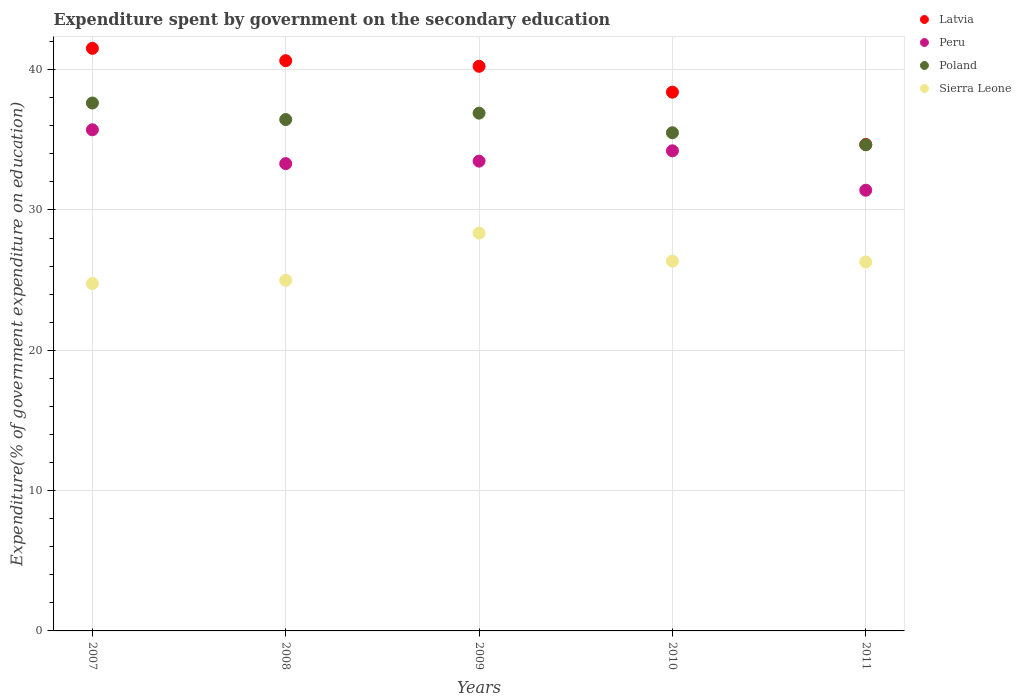Is the number of dotlines equal to the number of legend labels?
Ensure brevity in your answer.  Yes. What is the expenditure spent by government on the secondary education in Poland in 2009?
Ensure brevity in your answer.  36.9. Across all years, what is the maximum expenditure spent by government on the secondary education in Peru?
Make the answer very short. 35.71. Across all years, what is the minimum expenditure spent by government on the secondary education in Latvia?
Your response must be concise. 34.67. What is the total expenditure spent by government on the secondary education in Sierra Leone in the graph?
Offer a terse response. 130.74. What is the difference between the expenditure spent by government on the secondary education in Sierra Leone in 2007 and that in 2009?
Your answer should be very brief. -3.59. What is the difference between the expenditure spent by government on the secondary education in Sierra Leone in 2007 and the expenditure spent by government on the secondary education in Poland in 2009?
Offer a very short reply. -12.14. What is the average expenditure spent by government on the secondary education in Poland per year?
Your answer should be compact. 36.22. In the year 2011, what is the difference between the expenditure spent by government on the secondary education in Poland and expenditure spent by government on the secondary education in Peru?
Your answer should be very brief. 3.24. In how many years, is the expenditure spent by government on the secondary education in Poland greater than 10 %?
Provide a short and direct response. 5. What is the ratio of the expenditure spent by government on the secondary education in Latvia in 2007 to that in 2008?
Your response must be concise. 1.02. Is the expenditure spent by government on the secondary education in Peru in 2008 less than that in 2011?
Provide a succinct answer. No. What is the difference between the highest and the second highest expenditure spent by government on the secondary education in Poland?
Your answer should be very brief. 0.72. What is the difference between the highest and the lowest expenditure spent by government on the secondary education in Peru?
Provide a short and direct response. 4.31. In how many years, is the expenditure spent by government on the secondary education in Poland greater than the average expenditure spent by government on the secondary education in Poland taken over all years?
Offer a very short reply. 3. Is the sum of the expenditure spent by government on the secondary education in Sierra Leone in 2007 and 2010 greater than the maximum expenditure spent by government on the secondary education in Poland across all years?
Give a very brief answer. Yes. Is it the case that in every year, the sum of the expenditure spent by government on the secondary education in Latvia and expenditure spent by government on the secondary education in Sierra Leone  is greater than the expenditure spent by government on the secondary education in Poland?
Give a very brief answer. Yes. How many years are there in the graph?
Offer a terse response. 5. Where does the legend appear in the graph?
Your answer should be very brief. Top right. How many legend labels are there?
Offer a very short reply. 4. How are the legend labels stacked?
Make the answer very short. Vertical. What is the title of the graph?
Give a very brief answer. Expenditure spent by government on the secondary education. Does "Uruguay" appear as one of the legend labels in the graph?
Provide a short and direct response. No. What is the label or title of the X-axis?
Your response must be concise. Years. What is the label or title of the Y-axis?
Keep it short and to the point. Expenditure(% of government expenditure on education). What is the Expenditure(% of government expenditure on education) in Latvia in 2007?
Offer a terse response. 41.52. What is the Expenditure(% of government expenditure on education) in Peru in 2007?
Provide a short and direct response. 35.71. What is the Expenditure(% of government expenditure on education) of Poland in 2007?
Provide a short and direct response. 37.62. What is the Expenditure(% of government expenditure on education) of Sierra Leone in 2007?
Make the answer very short. 24.76. What is the Expenditure(% of government expenditure on education) of Latvia in 2008?
Your answer should be very brief. 40.64. What is the Expenditure(% of government expenditure on education) of Peru in 2008?
Your answer should be compact. 33.3. What is the Expenditure(% of government expenditure on education) in Poland in 2008?
Your answer should be very brief. 36.44. What is the Expenditure(% of government expenditure on education) of Sierra Leone in 2008?
Give a very brief answer. 24.99. What is the Expenditure(% of government expenditure on education) in Latvia in 2009?
Offer a very short reply. 40.24. What is the Expenditure(% of government expenditure on education) in Peru in 2009?
Offer a terse response. 33.48. What is the Expenditure(% of government expenditure on education) of Poland in 2009?
Offer a terse response. 36.9. What is the Expenditure(% of government expenditure on education) of Sierra Leone in 2009?
Offer a very short reply. 28.35. What is the Expenditure(% of government expenditure on education) of Latvia in 2010?
Make the answer very short. 38.39. What is the Expenditure(% of government expenditure on education) in Peru in 2010?
Ensure brevity in your answer.  34.22. What is the Expenditure(% of government expenditure on education) in Poland in 2010?
Your answer should be very brief. 35.5. What is the Expenditure(% of government expenditure on education) in Sierra Leone in 2010?
Your response must be concise. 26.36. What is the Expenditure(% of government expenditure on education) of Latvia in 2011?
Provide a short and direct response. 34.67. What is the Expenditure(% of government expenditure on education) of Peru in 2011?
Offer a terse response. 31.41. What is the Expenditure(% of government expenditure on education) of Poland in 2011?
Offer a terse response. 34.64. What is the Expenditure(% of government expenditure on education) of Sierra Leone in 2011?
Make the answer very short. 26.29. Across all years, what is the maximum Expenditure(% of government expenditure on education) of Latvia?
Keep it short and to the point. 41.52. Across all years, what is the maximum Expenditure(% of government expenditure on education) of Peru?
Your response must be concise. 35.71. Across all years, what is the maximum Expenditure(% of government expenditure on education) in Poland?
Offer a very short reply. 37.62. Across all years, what is the maximum Expenditure(% of government expenditure on education) in Sierra Leone?
Your answer should be compact. 28.35. Across all years, what is the minimum Expenditure(% of government expenditure on education) of Latvia?
Provide a succinct answer. 34.67. Across all years, what is the minimum Expenditure(% of government expenditure on education) of Peru?
Keep it short and to the point. 31.41. Across all years, what is the minimum Expenditure(% of government expenditure on education) in Poland?
Give a very brief answer. 34.64. Across all years, what is the minimum Expenditure(% of government expenditure on education) of Sierra Leone?
Your answer should be compact. 24.76. What is the total Expenditure(% of government expenditure on education) in Latvia in the graph?
Your answer should be very brief. 195.45. What is the total Expenditure(% of government expenditure on education) of Peru in the graph?
Provide a succinct answer. 168.11. What is the total Expenditure(% of government expenditure on education) in Poland in the graph?
Offer a terse response. 181.11. What is the total Expenditure(% of government expenditure on education) of Sierra Leone in the graph?
Keep it short and to the point. 130.74. What is the difference between the Expenditure(% of government expenditure on education) of Latvia in 2007 and that in 2008?
Keep it short and to the point. 0.88. What is the difference between the Expenditure(% of government expenditure on education) in Peru in 2007 and that in 2008?
Offer a very short reply. 2.41. What is the difference between the Expenditure(% of government expenditure on education) of Poland in 2007 and that in 2008?
Make the answer very short. 1.18. What is the difference between the Expenditure(% of government expenditure on education) in Sierra Leone in 2007 and that in 2008?
Your answer should be very brief. -0.23. What is the difference between the Expenditure(% of government expenditure on education) of Latvia in 2007 and that in 2009?
Your answer should be very brief. 1.28. What is the difference between the Expenditure(% of government expenditure on education) of Peru in 2007 and that in 2009?
Ensure brevity in your answer.  2.23. What is the difference between the Expenditure(% of government expenditure on education) in Poland in 2007 and that in 2009?
Give a very brief answer. 0.72. What is the difference between the Expenditure(% of government expenditure on education) in Sierra Leone in 2007 and that in 2009?
Provide a succinct answer. -3.59. What is the difference between the Expenditure(% of government expenditure on education) of Latvia in 2007 and that in 2010?
Provide a succinct answer. 3.12. What is the difference between the Expenditure(% of government expenditure on education) of Peru in 2007 and that in 2010?
Ensure brevity in your answer.  1.5. What is the difference between the Expenditure(% of government expenditure on education) in Poland in 2007 and that in 2010?
Provide a short and direct response. 2.12. What is the difference between the Expenditure(% of government expenditure on education) in Sierra Leone in 2007 and that in 2010?
Provide a succinct answer. -1.6. What is the difference between the Expenditure(% of government expenditure on education) in Latvia in 2007 and that in 2011?
Provide a short and direct response. 6.85. What is the difference between the Expenditure(% of government expenditure on education) of Peru in 2007 and that in 2011?
Make the answer very short. 4.31. What is the difference between the Expenditure(% of government expenditure on education) of Poland in 2007 and that in 2011?
Provide a short and direct response. 2.98. What is the difference between the Expenditure(% of government expenditure on education) in Sierra Leone in 2007 and that in 2011?
Your answer should be compact. -1.54. What is the difference between the Expenditure(% of government expenditure on education) of Latvia in 2008 and that in 2009?
Offer a very short reply. 0.4. What is the difference between the Expenditure(% of government expenditure on education) of Peru in 2008 and that in 2009?
Provide a succinct answer. -0.18. What is the difference between the Expenditure(% of government expenditure on education) in Poland in 2008 and that in 2009?
Your response must be concise. -0.46. What is the difference between the Expenditure(% of government expenditure on education) of Sierra Leone in 2008 and that in 2009?
Your answer should be very brief. -3.36. What is the difference between the Expenditure(% of government expenditure on education) of Latvia in 2008 and that in 2010?
Your response must be concise. 2.24. What is the difference between the Expenditure(% of government expenditure on education) of Peru in 2008 and that in 2010?
Offer a very short reply. -0.91. What is the difference between the Expenditure(% of government expenditure on education) in Poland in 2008 and that in 2010?
Keep it short and to the point. 0.94. What is the difference between the Expenditure(% of government expenditure on education) of Sierra Leone in 2008 and that in 2010?
Make the answer very short. -1.37. What is the difference between the Expenditure(% of government expenditure on education) in Latvia in 2008 and that in 2011?
Your answer should be compact. 5.97. What is the difference between the Expenditure(% of government expenditure on education) in Peru in 2008 and that in 2011?
Ensure brevity in your answer.  1.9. What is the difference between the Expenditure(% of government expenditure on education) in Poland in 2008 and that in 2011?
Offer a very short reply. 1.8. What is the difference between the Expenditure(% of government expenditure on education) in Sierra Leone in 2008 and that in 2011?
Offer a terse response. -1.31. What is the difference between the Expenditure(% of government expenditure on education) of Latvia in 2009 and that in 2010?
Your answer should be very brief. 1.84. What is the difference between the Expenditure(% of government expenditure on education) in Peru in 2009 and that in 2010?
Your answer should be compact. -0.74. What is the difference between the Expenditure(% of government expenditure on education) in Poland in 2009 and that in 2010?
Provide a short and direct response. 1.4. What is the difference between the Expenditure(% of government expenditure on education) of Sierra Leone in 2009 and that in 2010?
Make the answer very short. 1.99. What is the difference between the Expenditure(% of government expenditure on education) in Latvia in 2009 and that in 2011?
Provide a short and direct response. 5.57. What is the difference between the Expenditure(% of government expenditure on education) of Peru in 2009 and that in 2011?
Provide a succinct answer. 2.07. What is the difference between the Expenditure(% of government expenditure on education) of Poland in 2009 and that in 2011?
Keep it short and to the point. 2.25. What is the difference between the Expenditure(% of government expenditure on education) of Sierra Leone in 2009 and that in 2011?
Give a very brief answer. 2.06. What is the difference between the Expenditure(% of government expenditure on education) in Latvia in 2010 and that in 2011?
Keep it short and to the point. 3.73. What is the difference between the Expenditure(% of government expenditure on education) of Peru in 2010 and that in 2011?
Give a very brief answer. 2.81. What is the difference between the Expenditure(% of government expenditure on education) in Poland in 2010 and that in 2011?
Offer a terse response. 0.86. What is the difference between the Expenditure(% of government expenditure on education) in Sierra Leone in 2010 and that in 2011?
Your answer should be compact. 0.06. What is the difference between the Expenditure(% of government expenditure on education) of Latvia in 2007 and the Expenditure(% of government expenditure on education) of Peru in 2008?
Provide a succinct answer. 8.22. What is the difference between the Expenditure(% of government expenditure on education) in Latvia in 2007 and the Expenditure(% of government expenditure on education) in Poland in 2008?
Offer a very short reply. 5.08. What is the difference between the Expenditure(% of government expenditure on education) of Latvia in 2007 and the Expenditure(% of government expenditure on education) of Sierra Leone in 2008?
Your response must be concise. 16.53. What is the difference between the Expenditure(% of government expenditure on education) in Peru in 2007 and the Expenditure(% of government expenditure on education) in Poland in 2008?
Offer a terse response. -0.73. What is the difference between the Expenditure(% of government expenditure on education) of Peru in 2007 and the Expenditure(% of government expenditure on education) of Sierra Leone in 2008?
Offer a terse response. 10.73. What is the difference between the Expenditure(% of government expenditure on education) of Poland in 2007 and the Expenditure(% of government expenditure on education) of Sierra Leone in 2008?
Your answer should be compact. 12.63. What is the difference between the Expenditure(% of government expenditure on education) in Latvia in 2007 and the Expenditure(% of government expenditure on education) in Peru in 2009?
Provide a short and direct response. 8.04. What is the difference between the Expenditure(% of government expenditure on education) in Latvia in 2007 and the Expenditure(% of government expenditure on education) in Poland in 2009?
Make the answer very short. 4.62. What is the difference between the Expenditure(% of government expenditure on education) of Latvia in 2007 and the Expenditure(% of government expenditure on education) of Sierra Leone in 2009?
Your answer should be very brief. 13.17. What is the difference between the Expenditure(% of government expenditure on education) of Peru in 2007 and the Expenditure(% of government expenditure on education) of Poland in 2009?
Your response must be concise. -1.19. What is the difference between the Expenditure(% of government expenditure on education) in Peru in 2007 and the Expenditure(% of government expenditure on education) in Sierra Leone in 2009?
Your answer should be compact. 7.36. What is the difference between the Expenditure(% of government expenditure on education) of Poland in 2007 and the Expenditure(% of government expenditure on education) of Sierra Leone in 2009?
Make the answer very short. 9.27. What is the difference between the Expenditure(% of government expenditure on education) in Latvia in 2007 and the Expenditure(% of government expenditure on education) in Peru in 2010?
Ensure brevity in your answer.  7.3. What is the difference between the Expenditure(% of government expenditure on education) in Latvia in 2007 and the Expenditure(% of government expenditure on education) in Poland in 2010?
Your response must be concise. 6.01. What is the difference between the Expenditure(% of government expenditure on education) in Latvia in 2007 and the Expenditure(% of government expenditure on education) in Sierra Leone in 2010?
Your response must be concise. 15.16. What is the difference between the Expenditure(% of government expenditure on education) of Peru in 2007 and the Expenditure(% of government expenditure on education) of Poland in 2010?
Keep it short and to the point. 0.21. What is the difference between the Expenditure(% of government expenditure on education) of Peru in 2007 and the Expenditure(% of government expenditure on education) of Sierra Leone in 2010?
Ensure brevity in your answer.  9.36. What is the difference between the Expenditure(% of government expenditure on education) of Poland in 2007 and the Expenditure(% of government expenditure on education) of Sierra Leone in 2010?
Your answer should be very brief. 11.26. What is the difference between the Expenditure(% of government expenditure on education) of Latvia in 2007 and the Expenditure(% of government expenditure on education) of Peru in 2011?
Provide a short and direct response. 10.11. What is the difference between the Expenditure(% of government expenditure on education) of Latvia in 2007 and the Expenditure(% of government expenditure on education) of Poland in 2011?
Offer a terse response. 6.87. What is the difference between the Expenditure(% of government expenditure on education) of Latvia in 2007 and the Expenditure(% of government expenditure on education) of Sierra Leone in 2011?
Ensure brevity in your answer.  15.22. What is the difference between the Expenditure(% of government expenditure on education) in Peru in 2007 and the Expenditure(% of government expenditure on education) in Poland in 2011?
Provide a short and direct response. 1.07. What is the difference between the Expenditure(% of government expenditure on education) in Peru in 2007 and the Expenditure(% of government expenditure on education) in Sierra Leone in 2011?
Ensure brevity in your answer.  9.42. What is the difference between the Expenditure(% of government expenditure on education) of Poland in 2007 and the Expenditure(% of government expenditure on education) of Sierra Leone in 2011?
Give a very brief answer. 11.33. What is the difference between the Expenditure(% of government expenditure on education) of Latvia in 2008 and the Expenditure(% of government expenditure on education) of Peru in 2009?
Give a very brief answer. 7.16. What is the difference between the Expenditure(% of government expenditure on education) in Latvia in 2008 and the Expenditure(% of government expenditure on education) in Poland in 2009?
Provide a short and direct response. 3.74. What is the difference between the Expenditure(% of government expenditure on education) in Latvia in 2008 and the Expenditure(% of government expenditure on education) in Sierra Leone in 2009?
Ensure brevity in your answer.  12.29. What is the difference between the Expenditure(% of government expenditure on education) of Peru in 2008 and the Expenditure(% of government expenditure on education) of Poland in 2009?
Give a very brief answer. -3.6. What is the difference between the Expenditure(% of government expenditure on education) in Peru in 2008 and the Expenditure(% of government expenditure on education) in Sierra Leone in 2009?
Ensure brevity in your answer.  4.95. What is the difference between the Expenditure(% of government expenditure on education) of Poland in 2008 and the Expenditure(% of government expenditure on education) of Sierra Leone in 2009?
Keep it short and to the point. 8.09. What is the difference between the Expenditure(% of government expenditure on education) in Latvia in 2008 and the Expenditure(% of government expenditure on education) in Peru in 2010?
Offer a terse response. 6.42. What is the difference between the Expenditure(% of government expenditure on education) of Latvia in 2008 and the Expenditure(% of government expenditure on education) of Poland in 2010?
Your answer should be compact. 5.13. What is the difference between the Expenditure(% of government expenditure on education) of Latvia in 2008 and the Expenditure(% of government expenditure on education) of Sierra Leone in 2010?
Ensure brevity in your answer.  14.28. What is the difference between the Expenditure(% of government expenditure on education) of Peru in 2008 and the Expenditure(% of government expenditure on education) of Poland in 2010?
Offer a terse response. -2.2. What is the difference between the Expenditure(% of government expenditure on education) in Peru in 2008 and the Expenditure(% of government expenditure on education) in Sierra Leone in 2010?
Make the answer very short. 6.95. What is the difference between the Expenditure(% of government expenditure on education) in Poland in 2008 and the Expenditure(% of government expenditure on education) in Sierra Leone in 2010?
Give a very brief answer. 10.09. What is the difference between the Expenditure(% of government expenditure on education) of Latvia in 2008 and the Expenditure(% of government expenditure on education) of Peru in 2011?
Offer a terse response. 9.23. What is the difference between the Expenditure(% of government expenditure on education) in Latvia in 2008 and the Expenditure(% of government expenditure on education) in Poland in 2011?
Your response must be concise. 5.99. What is the difference between the Expenditure(% of government expenditure on education) of Latvia in 2008 and the Expenditure(% of government expenditure on education) of Sierra Leone in 2011?
Offer a very short reply. 14.34. What is the difference between the Expenditure(% of government expenditure on education) in Peru in 2008 and the Expenditure(% of government expenditure on education) in Poland in 2011?
Your answer should be very brief. -1.34. What is the difference between the Expenditure(% of government expenditure on education) of Peru in 2008 and the Expenditure(% of government expenditure on education) of Sierra Leone in 2011?
Make the answer very short. 7.01. What is the difference between the Expenditure(% of government expenditure on education) in Poland in 2008 and the Expenditure(% of government expenditure on education) in Sierra Leone in 2011?
Your answer should be very brief. 10.15. What is the difference between the Expenditure(% of government expenditure on education) in Latvia in 2009 and the Expenditure(% of government expenditure on education) in Peru in 2010?
Offer a very short reply. 6.02. What is the difference between the Expenditure(% of government expenditure on education) in Latvia in 2009 and the Expenditure(% of government expenditure on education) in Poland in 2010?
Make the answer very short. 4.73. What is the difference between the Expenditure(% of government expenditure on education) in Latvia in 2009 and the Expenditure(% of government expenditure on education) in Sierra Leone in 2010?
Provide a short and direct response. 13.88. What is the difference between the Expenditure(% of government expenditure on education) in Peru in 2009 and the Expenditure(% of government expenditure on education) in Poland in 2010?
Provide a succinct answer. -2.02. What is the difference between the Expenditure(% of government expenditure on education) of Peru in 2009 and the Expenditure(% of government expenditure on education) of Sierra Leone in 2010?
Your answer should be very brief. 7.12. What is the difference between the Expenditure(% of government expenditure on education) in Poland in 2009 and the Expenditure(% of government expenditure on education) in Sierra Leone in 2010?
Give a very brief answer. 10.54. What is the difference between the Expenditure(% of government expenditure on education) of Latvia in 2009 and the Expenditure(% of government expenditure on education) of Peru in 2011?
Keep it short and to the point. 8.83. What is the difference between the Expenditure(% of government expenditure on education) of Latvia in 2009 and the Expenditure(% of government expenditure on education) of Poland in 2011?
Offer a very short reply. 5.59. What is the difference between the Expenditure(% of government expenditure on education) of Latvia in 2009 and the Expenditure(% of government expenditure on education) of Sierra Leone in 2011?
Offer a very short reply. 13.94. What is the difference between the Expenditure(% of government expenditure on education) in Peru in 2009 and the Expenditure(% of government expenditure on education) in Poland in 2011?
Ensure brevity in your answer.  -1.17. What is the difference between the Expenditure(% of government expenditure on education) in Peru in 2009 and the Expenditure(% of government expenditure on education) in Sierra Leone in 2011?
Ensure brevity in your answer.  7.18. What is the difference between the Expenditure(% of government expenditure on education) in Poland in 2009 and the Expenditure(% of government expenditure on education) in Sierra Leone in 2011?
Provide a succinct answer. 10.61. What is the difference between the Expenditure(% of government expenditure on education) in Latvia in 2010 and the Expenditure(% of government expenditure on education) in Peru in 2011?
Provide a succinct answer. 6.99. What is the difference between the Expenditure(% of government expenditure on education) in Latvia in 2010 and the Expenditure(% of government expenditure on education) in Poland in 2011?
Keep it short and to the point. 3.75. What is the difference between the Expenditure(% of government expenditure on education) of Latvia in 2010 and the Expenditure(% of government expenditure on education) of Sierra Leone in 2011?
Keep it short and to the point. 12.1. What is the difference between the Expenditure(% of government expenditure on education) of Peru in 2010 and the Expenditure(% of government expenditure on education) of Poland in 2011?
Make the answer very short. -0.43. What is the difference between the Expenditure(% of government expenditure on education) in Peru in 2010 and the Expenditure(% of government expenditure on education) in Sierra Leone in 2011?
Offer a terse response. 7.92. What is the difference between the Expenditure(% of government expenditure on education) of Poland in 2010 and the Expenditure(% of government expenditure on education) of Sierra Leone in 2011?
Ensure brevity in your answer.  9.21. What is the average Expenditure(% of government expenditure on education) of Latvia per year?
Offer a very short reply. 39.09. What is the average Expenditure(% of government expenditure on education) of Peru per year?
Offer a very short reply. 33.62. What is the average Expenditure(% of government expenditure on education) of Poland per year?
Your answer should be compact. 36.22. What is the average Expenditure(% of government expenditure on education) in Sierra Leone per year?
Provide a short and direct response. 26.15. In the year 2007, what is the difference between the Expenditure(% of government expenditure on education) in Latvia and Expenditure(% of government expenditure on education) in Peru?
Give a very brief answer. 5.8. In the year 2007, what is the difference between the Expenditure(% of government expenditure on education) of Latvia and Expenditure(% of government expenditure on education) of Poland?
Your answer should be very brief. 3.9. In the year 2007, what is the difference between the Expenditure(% of government expenditure on education) of Latvia and Expenditure(% of government expenditure on education) of Sierra Leone?
Give a very brief answer. 16.76. In the year 2007, what is the difference between the Expenditure(% of government expenditure on education) of Peru and Expenditure(% of government expenditure on education) of Poland?
Your response must be concise. -1.91. In the year 2007, what is the difference between the Expenditure(% of government expenditure on education) in Peru and Expenditure(% of government expenditure on education) in Sierra Leone?
Your answer should be compact. 10.96. In the year 2007, what is the difference between the Expenditure(% of government expenditure on education) of Poland and Expenditure(% of government expenditure on education) of Sierra Leone?
Offer a terse response. 12.87. In the year 2008, what is the difference between the Expenditure(% of government expenditure on education) of Latvia and Expenditure(% of government expenditure on education) of Peru?
Provide a succinct answer. 7.33. In the year 2008, what is the difference between the Expenditure(% of government expenditure on education) of Latvia and Expenditure(% of government expenditure on education) of Poland?
Your response must be concise. 4.19. In the year 2008, what is the difference between the Expenditure(% of government expenditure on education) of Latvia and Expenditure(% of government expenditure on education) of Sierra Leone?
Offer a terse response. 15.65. In the year 2008, what is the difference between the Expenditure(% of government expenditure on education) of Peru and Expenditure(% of government expenditure on education) of Poland?
Your response must be concise. -3.14. In the year 2008, what is the difference between the Expenditure(% of government expenditure on education) in Peru and Expenditure(% of government expenditure on education) in Sierra Leone?
Keep it short and to the point. 8.31. In the year 2008, what is the difference between the Expenditure(% of government expenditure on education) of Poland and Expenditure(% of government expenditure on education) of Sierra Leone?
Offer a very short reply. 11.45. In the year 2009, what is the difference between the Expenditure(% of government expenditure on education) in Latvia and Expenditure(% of government expenditure on education) in Peru?
Offer a very short reply. 6.76. In the year 2009, what is the difference between the Expenditure(% of government expenditure on education) of Latvia and Expenditure(% of government expenditure on education) of Poland?
Offer a terse response. 3.34. In the year 2009, what is the difference between the Expenditure(% of government expenditure on education) in Latvia and Expenditure(% of government expenditure on education) in Sierra Leone?
Your answer should be compact. 11.89. In the year 2009, what is the difference between the Expenditure(% of government expenditure on education) of Peru and Expenditure(% of government expenditure on education) of Poland?
Ensure brevity in your answer.  -3.42. In the year 2009, what is the difference between the Expenditure(% of government expenditure on education) in Peru and Expenditure(% of government expenditure on education) in Sierra Leone?
Make the answer very short. 5.13. In the year 2009, what is the difference between the Expenditure(% of government expenditure on education) of Poland and Expenditure(% of government expenditure on education) of Sierra Leone?
Make the answer very short. 8.55. In the year 2010, what is the difference between the Expenditure(% of government expenditure on education) in Latvia and Expenditure(% of government expenditure on education) in Peru?
Provide a short and direct response. 4.18. In the year 2010, what is the difference between the Expenditure(% of government expenditure on education) of Latvia and Expenditure(% of government expenditure on education) of Poland?
Offer a very short reply. 2.89. In the year 2010, what is the difference between the Expenditure(% of government expenditure on education) of Latvia and Expenditure(% of government expenditure on education) of Sierra Leone?
Give a very brief answer. 12.04. In the year 2010, what is the difference between the Expenditure(% of government expenditure on education) in Peru and Expenditure(% of government expenditure on education) in Poland?
Provide a short and direct response. -1.29. In the year 2010, what is the difference between the Expenditure(% of government expenditure on education) in Peru and Expenditure(% of government expenditure on education) in Sierra Leone?
Provide a succinct answer. 7.86. In the year 2010, what is the difference between the Expenditure(% of government expenditure on education) of Poland and Expenditure(% of government expenditure on education) of Sierra Leone?
Offer a terse response. 9.15. In the year 2011, what is the difference between the Expenditure(% of government expenditure on education) of Latvia and Expenditure(% of government expenditure on education) of Peru?
Keep it short and to the point. 3.26. In the year 2011, what is the difference between the Expenditure(% of government expenditure on education) of Latvia and Expenditure(% of government expenditure on education) of Poland?
Make the answer very short. 0.02. In the year 2011, what is the difference between the Expenditure(% of government expenditure on education) in Latvia and Expenditure(% of government expenditure on education) in Sierra Leone?
Ensure brevity in your answer.  8.37. In the year 2011, what is the difference between the Expenditure(% of government expenditure on education) in Peru and Expenditure(% of government expenditure on education) in Poland?
Your answer should be very brief. -3.24. In the year 2011, what is the difference between the Expenditure(% of government expenditure on education) of Peru and Expenditure(% of government expenditure on education) of Sierra Leone?
Offer a very short reply. 5.11. In the year 2011, what is the difference between the Expenditure(% of government expenditure on education) in Poland and Expenditure(% of government expenditure on education) in Sierra Leone?
Your response must be concise. 8.35. What is the ratio of the Expenditure(% of government expenditure on education) of Latvia in 2007 to that in 2008?
Your answer should be compact. 1.02. What is the ratio of the Expenditure(% of government expenditure on education) in Peru in 2007 to that in 2008?
Your answer should be very brief. 1.07. What is the ratio of the Expenditure(% of government expenditure on education) of Poland in 2007 to that in 2008?
Make the answer very short. 1.03. What is the ratio of the Expenditure(% of government expenditure on education) of Sierra Leone in 2007 to that in 2008?
Offer a terse response. 0.99. What is the ratio of the Expenditure(% of government expenditure on education) of Latvia in 2007 to that in 2009?
Give a very brief answer. 1.03. What is the ratio of the Expenditure(% of government expenditure on education) in Peru in 2007 to that in 2009?
Make the answer very short. 1.07. What is the ratio of the Expenditure(% of government expenditure on education) of Poland in 2007 to that in 2009?
Provide a succinct answer. 1.02. What is the ratio of the Expenditure(% of government expenditure on education) in Sierra Leone in 2007 to that in 2009?
Provide a short and direct response. 0.87. What is the ratio of the Expenditure(% of government expenditure on education) in Latvia in 2007 to that in 2010?
Provide a succinct answer. 1.08. What is the ratio of the Expenditure(% of government expenditure on education) of Peru in 2007 to that in 2010?
Give a very brief answer. 1.04. What is the ratio of the Expenditure(% of government expenditure on education) of Poland in 2007 to that in 2010?
Your response must be concise. 1.06. What is the ratio of the Expenditure(% of government expenditure on education) in Sierra Leone in 2007 to that in 2010?
Give a very brief answer. 0.94. What is the ratio of the Expenditure(% of government expenditure on education) of Latvia in 2007 to that in 2011?
Your response must be concise. 1.2. What is the ratio of the Expenditure(% of government expenditure on education) in Peru in 2007 to that in 2011?
Your response must be concise. 1.14. What is the ratio of the Expenditure(% of government expenditure on education) of Poland in 2007 to that in 2011?
Give a very brief answer. 1.09. What is the ratio of the Expenditure(% of government expenditure on education) in Sierra Leone in 2007 to that in 2011?
Your answer should be very brief. 0.94. What is the ratio of the Expenditure(% of government expenditure on education) of Latvia in 2008 to that in 2009?
Your answer should be very brief. 1.01. What is the ratio of the Expenditure(% of government expenditure on education) in Poland in 2008 to that in 2009?
Ensure brevity in your answer.  0.99. What is the ratio of the Expenditure(% of government expenditure on education) of Sierra Leone in 2008 to that in 2009?
Offer a terse response. 0.88. What is the ratio of the Expenditure(% of government expenditure on education) in Latvia in 2008 to that in 2010?
Offer a terse response. 1.06. What is the ratio of the Expenditure(% of government expenditure on education) in Peru in 2008 to that in 2010?
Make the answer very short. 0.97. What is the ratio of the Expenditure(% of government expenditure on education) of Poland in 2008 to that in 2010?
Offer a terse response. 1.03. What is the ratio of the Expenditure(% of government expenditure on education) of Sierra Leone in 2008 to that in 2010?
Offer a very short reply. 0.95. What is the ratio of the Expenditure(% of government expenditure on education) in Latvia in 2008 to that in 2011?
Provide a succinct answer. 1.17. What is the ratio of the Expenditure(% of government expenditure on education) in Peru in 2008 to that in 2011?
Provide a succinct answer. 1.06. What is the ratio of the Expenditure(% of government expenditure on education) in Poland in 2008 to that in 2011?
Offer a terse response. 1.05. What is the ratio of the Expenditure(% of government expenditure on education) in Sierra Leone in 2008 to that in 2011?
Make the answer very short. 0.95. What is the ratio of the Expenditure(% of government expenditure on education) of Latvia in 2009 to that in 2010?
Give a very brief answer. 1.05. What is the ratio of the Expenditure(% of government expenditure on education) in Peru in 2009 to that in 2010?
Provide a short and direct response. 0.98. What is the ratio of the Expenditure(% of government expenditure on education) of Poland in 2009 to that in 2010?
Offer a terse response. 1.04. What is the ratio of the Expenditure(% of government expenditure on education) in Sierra Leone in 2009 to that in 2010?
Provide a succinct answer. 1.08. What is the ratio of the Expenditure(% of government expenditure on education) of Latvia in 2009 to that in 2011?
Your answer should be very brief. 1.16. What is the ratio of the Expenditure(% of government expenditure on education) in Peru in 2009 to that in 2011?
Ensure brevity in your answer.  1.07. What is the ratio of the Expenditure(% of government expenditure on education) of Poland in 2009 to that in 2011?
Ensure brevity in your answer.  1.07. What is the ratio of the Expenditure(% of government expenditure on education) in Sierra Leone in 2009 to that in 2011?
Give a very brief answer. 1.08. What is the ratio of the Expenditure(% of government expenditure on education) of Latvia in 2010 to that in 2011?
Offer a very short reply. 1.11. What is the ratio of the Expenditure(% of government expenditure on education) in Peru in 2010 to that in 2011?
Make the answer very short. 1.09. What is the ratio of the Expenditure(% of government expenditure on education) in Poland in 2010 to that in 2011?
Offer a terse response. 1.02. What is the difference between the highest and the second highest Expenditure(% of government expenditure on education) of Latvia?
Offer a terse response. 0.88. What is the difference between the highest and the second highest Expenditure(% of government expenditure on education) of Peru?
Your response must be concise. 1.5. What is the difference between the highest and the second highest Expenditure(% of government expenditure on education) in Poland?
Provide a succinct answer. 0.72. What is the difference between the highest and the second highest Expenditure(% of government expenditure on education) in Sierra Leone?
Your answer should be compact. 1.99. What is the difference between the highest and the lowest Expenditure(% of government expenditure on education) of Latvia?
Keep it short and to the point. 6.85. What is the difference between the highest and the lowest Expenditure(% of government expenditure on education) in Peru?
Provide a succinct answer. 4.31. What is the difference between the highest and the lowest Expenditure(% of government expenditure on education) in Poland?
Provide a short and direct response. 2.98. What is the difference between the highest and the lowest Expenditure(% of government expenditure on education) in Sierra Leone?
Provide a short and direct response. 3.59. 